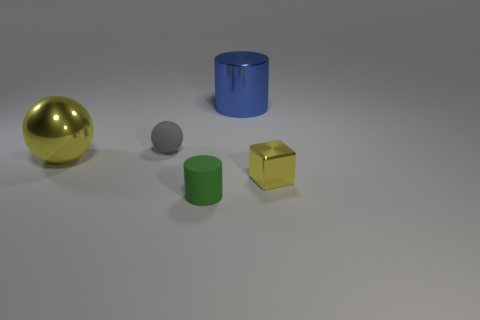What is the size of the yellow ball?
Make the answer very short. Large. Is the number of tiny gray matte things that are in front of the small rubber sphere greater than the number of tiny yellow metallic cubes?
Make the answer very short. No. What number of objects are behind the matte cylinder?
Offer a terse response. 4. Are there any matte objects that have the same size as the blue cylinder?
Provide a succinct answer. No. There is another rubber object that is the same shape as the large blue thing; what is its color?
Provide a succinct answer. Green. Are there the same number of purple metallic objects and small gray balls?
Offer a terse response. No. Is the size of the yellow object right of the big yellow object the same as the metallic object behind the gray matte object?
Your response must be concise. No. Are there any other big metallic objects of the same shape as the blue thing?
Offer a very short reply. No. Are there the same number of yellow things right of the blue thing and small rubber cylinders?
Your response must be concise. Yes. There is a gray rubber thing; is it the same size as the metallic object left of the tiny matte cylinder?
Offer a terse response. No. 